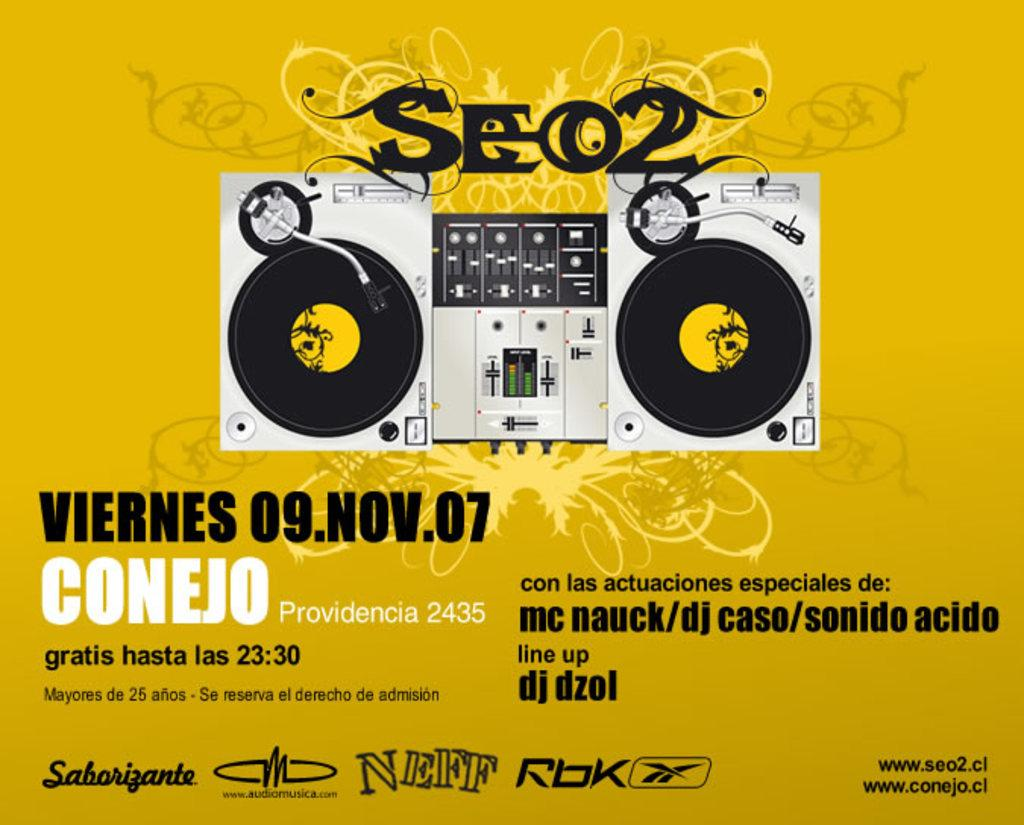<image>
Give a short and clear explanation of the subsequent image. An advertisement for SEO2 in November featuring DJ Dzol and others. 